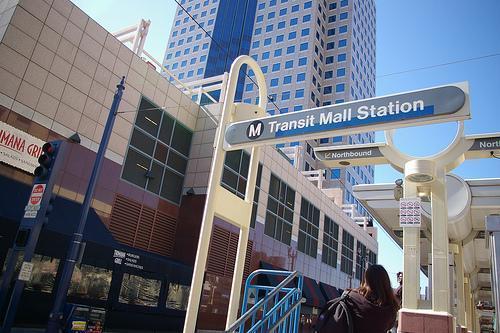How many persons are coming up the steps?
Give a very brief answer. 1. 